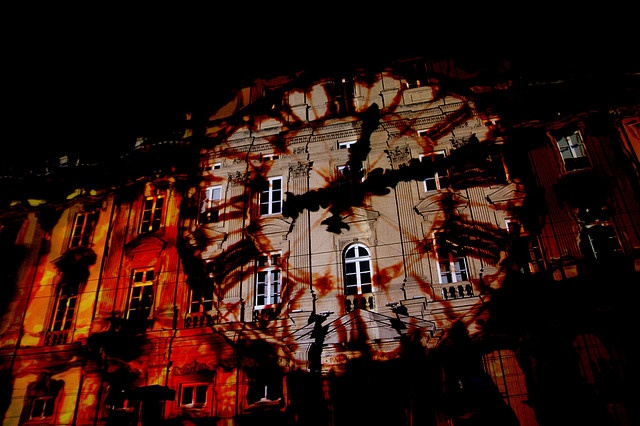Describe the objects in this image and their specific colors. I can see a clock in black, maroon, gray, and tan tones in this image. 